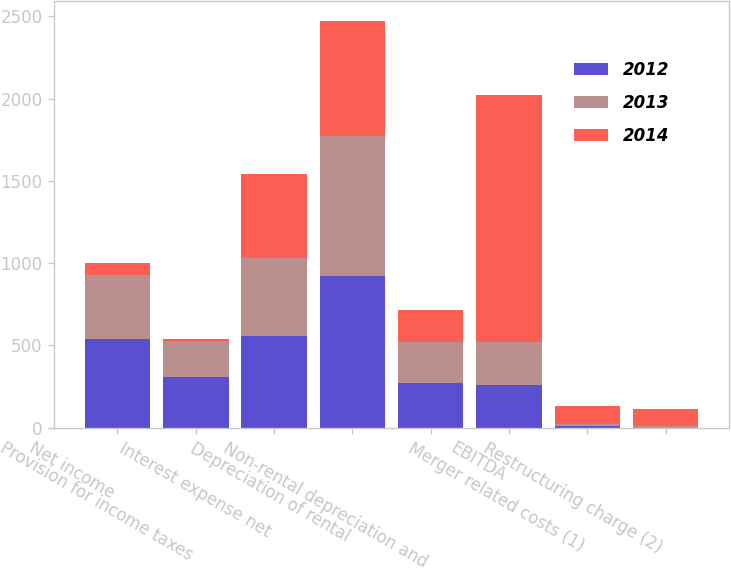Convert chart to OTSL. <chart><loc_0><loc_0><loc_500><loc_500><stacked_bar_chart><ecel><fcel>Net income<fcel>Provision for income taxes<fcel>Interest expense net<fcel>Depreciation of rental<fcel>Non-rental depreciation and<fcel>EBITDA<fcel>Merger related costs (1)<fcel>Restructuring charge (2)<nl><fcel>2012<fcel>540<fcel>310<fcel>555<fcel>921<fcel>273<fcel>259.5<fcel>11<fcel>1<nl><fcel>2013<fcel>387<fcel>218<fcel>475<fcel>852<fcel>246<fcel>259.5<fcel>9<fcel>12<nl><fcel>2014<fcel>75<fcel>13<fcel>512<fcel>699<fcel>198<fcel>1501<fcel>111<fcel>99<nl></chart> 